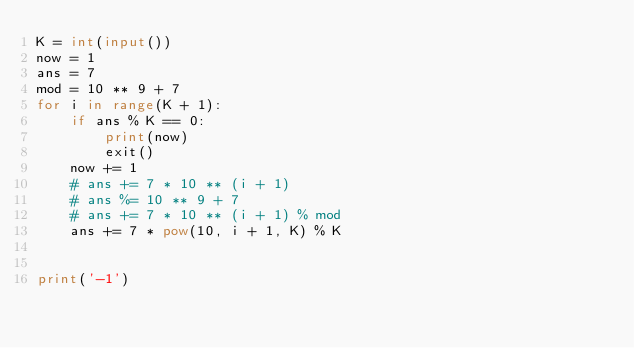<code> <loc_0><loc_0><loc_500><loc_500><_Python_>K = int(input())
now = 1
ans = 7
mod = 10 ** 9 + 7
for i in range(K + 1):
    if ans % K == 0:
        print(now)
        exit()
    now += 1
    # ans += 7 * 10 ** (i + 1)
    # ans %= 10 ** 9 + 7
    # ans += 7 * 10 ** (i + 1) % mod
    ans += 7 * pow(10, i + 1, K) % K


print('-1')</code> 